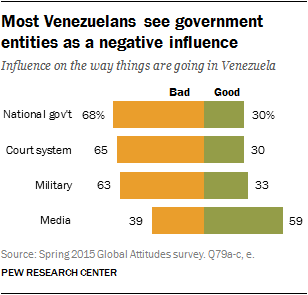Identify some key points in this picture. The total percentage of military influence is 0.96. The two bars in the chart represent good and bad outcomes. 